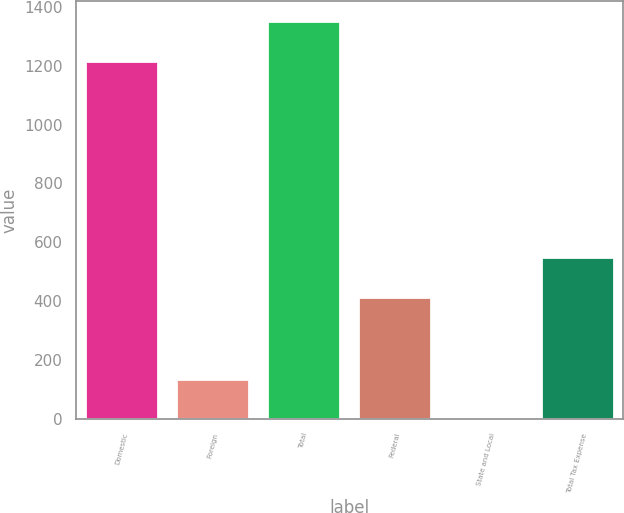Convert chart to OTSL. <chart><loc_0><loc_0><loc_500><loc_500><bar_chart><fcel>Domestic<fcel>Foreign<fcel>Total<fcel>Federal<fcel>State and Local<fcel>Total Tax Expense<nl><fcel>1215.8<fcel>135.04<fcel>1350.54<fcel>414.8<fcel>0.3<fcel>549.54<nl></chart> 